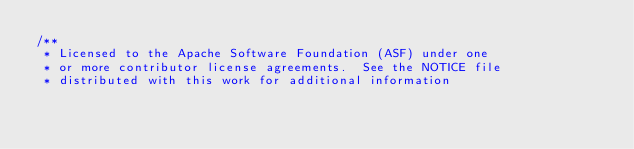Convert code to text. <code><loc_0><loc_0><loc_500><loc_500><_Java_>/**
 * Licensed to the Apache Software Foundation (ASF) under one
 * or more contributor license agreements.  See the NOTICE file
 * distributed with this work for additional information</code> 